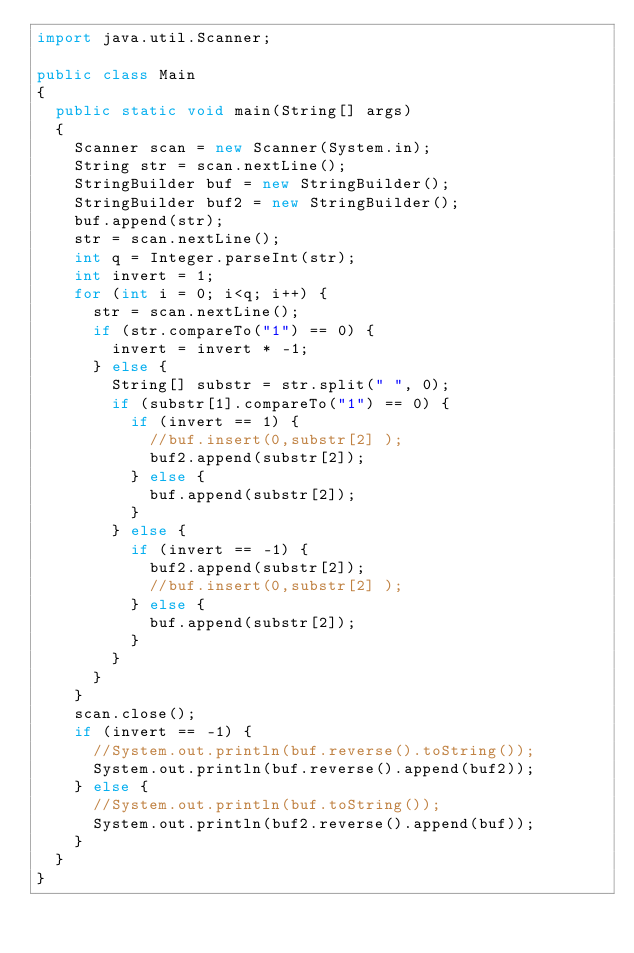Convert code to text. <code><loc_0><loc_0><loc_500><loc_500><_Java_>import java.util.Scanner;

public class Main
{
	public static void main(String[] args)
	{
		Scanner scan = new Scanner(System.in);
		String str = scan.nextLine();
		StringBuilder buf = new StringBuilder();
		StringBuilder buf2 = new StringBuilder();
		buf.append(str);
		str = scan.nextLine();
		int q = Integer.parseInt(str);
		int invert = 1;
		for (int i = 0; i<q; i++) {
			str = scan.nextLine();
			if (str.compareTo("1") == 0) {
				invert = invert * -1;
			} else {
				String[] substr = str.split(" ", 0);
				if (substr[1].compareTo("1") == 0) {
					if (invert == 1) {
						//buf.insert(0,substr[2] );
						buf2.append(substr[2]);
					} else {
						buf.append(substr[2]);
					}
				} else {
					if (invert == -1) {
						buf2.append(substr[2]);
						//buf.insert(0,substr[2] );
					} else {
						buf.append(substr[2]);
					}
				}
			}
		}
		scan.close();
		if (invert == -1) {
			//System.out.println(buf.reverse().toString());
			System.out.println(buf.reverse().append(buf2));
 		} else {
 			//System.out.println(buf.toString());
 			System.out.println(buf2.reverse().append(buf));
 		}
	}
}
</code> 